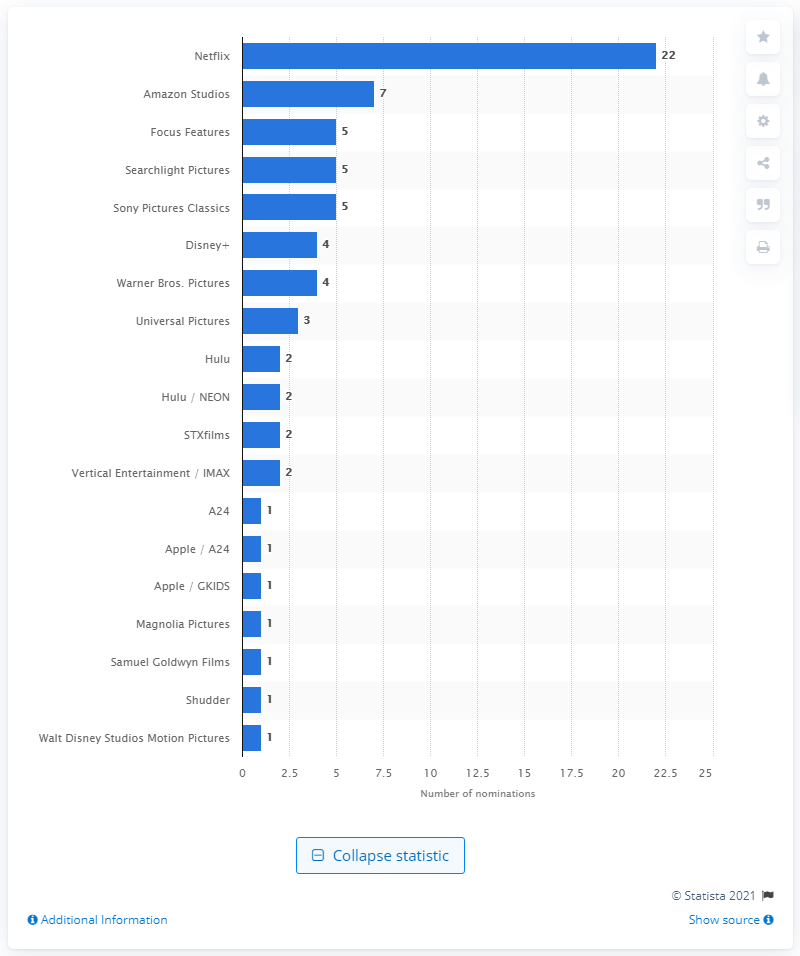Point out several critical features in this image. Netflix received 22 nominations for the 2021 Golden Globes. 